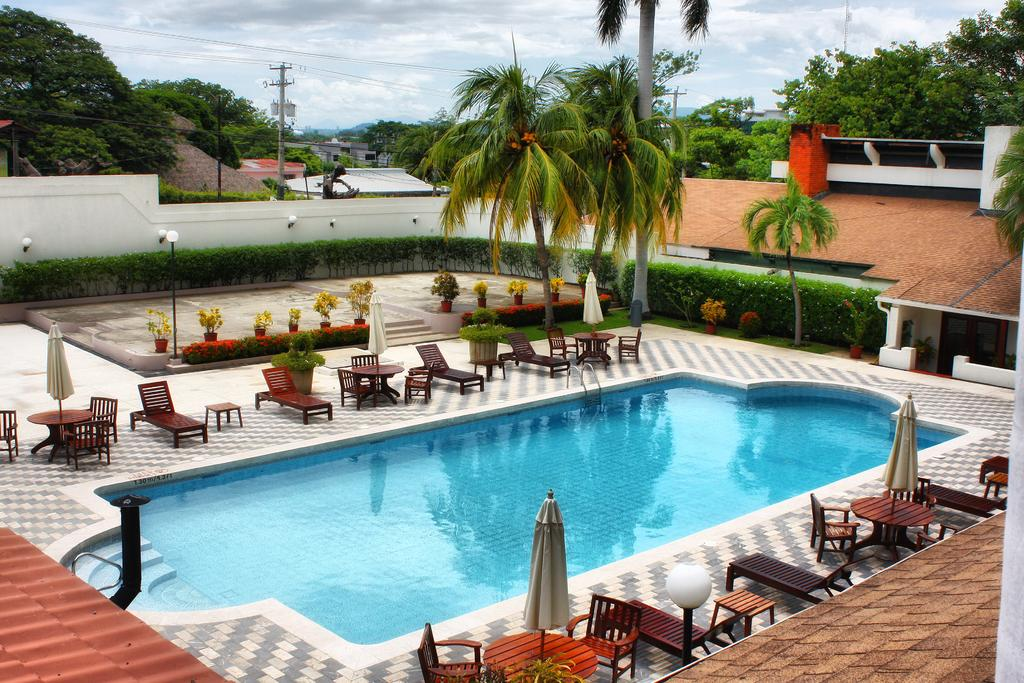What is the main feature of the image? There is a swimming pool in the image. What other structures can be seen around the swimming pool? There are shacks, houses, and buildings in the image. Are there any objects or features related to relaxation or leisure? Yes, there is a chair in the image. What can be seen in the sky in the image? The sky is visible in the image, with clouds present. What type of record can be seen spinning on the turntable in the image? There is no turntable or record present in the image; it features a swimming pool and surrounding structures. What kind of meal is being prepared in the image? There is no meal preparation visible in the image. 